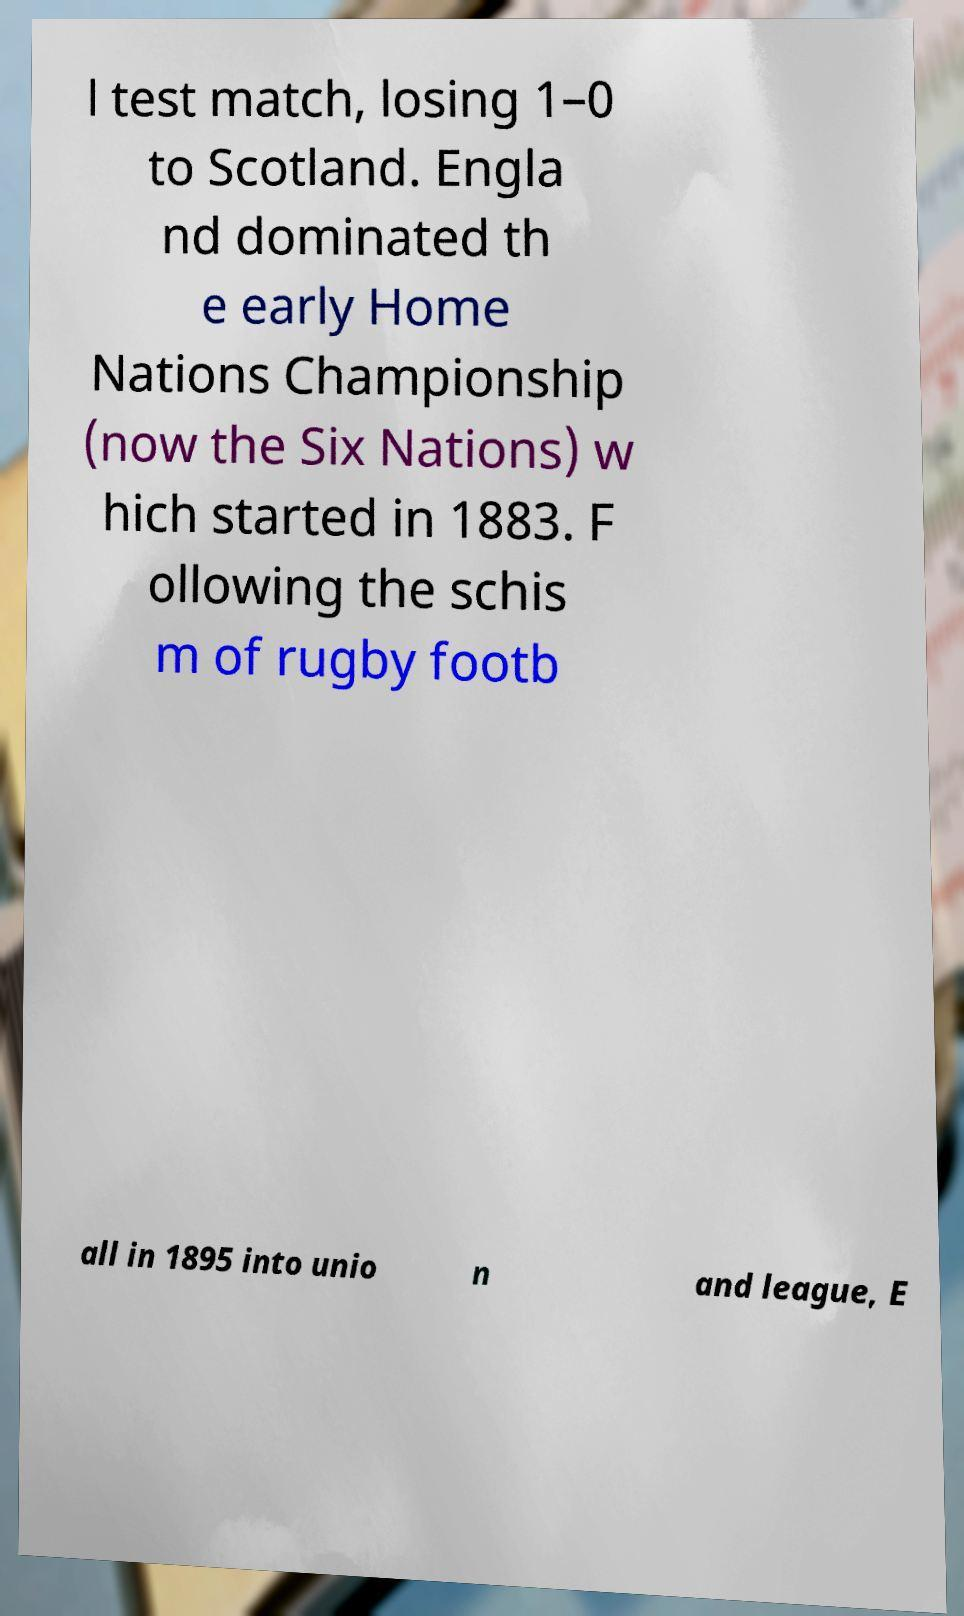Please identify and transcribe the text found in this image. l test match, losing 1–0 to Scotland. Engla nd dominated th e early Home Nations Championship (now the Six Nations) w hich started in 1883. F ollowing the schis m of rugby footb all in 1895 into unio n and league, E 